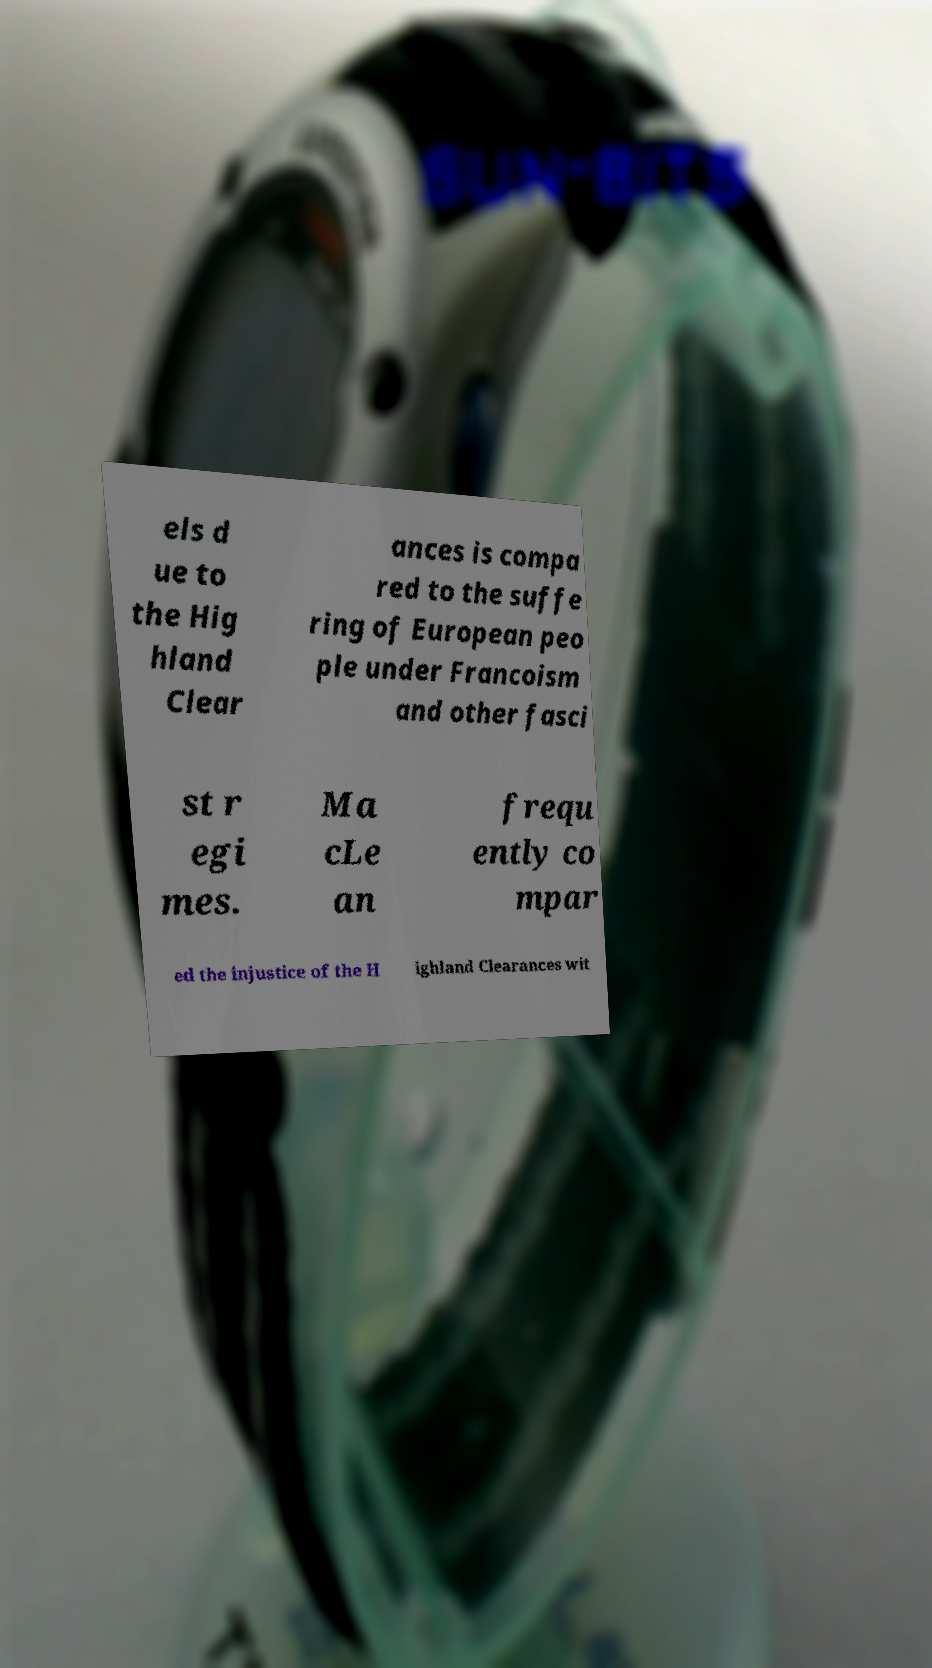Can you accurately transcribe the text from the provided image for me? els d ue to the Hig hland Clear ances is compa red to the suffe ring of European peo ple under Francoism and other fasci st r egi mes. Ma cLe an frequ ently co mpar ed the injustice of the H ighland Clearances wit 